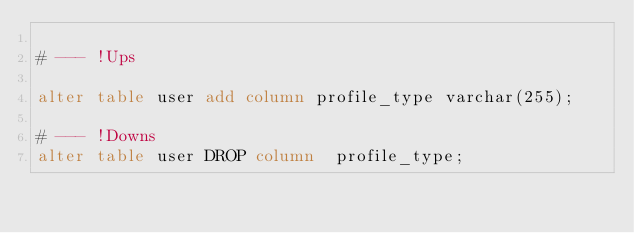Convert code to text. <code><loc_0><loc_0><loc_500><loc_500><_SQL_>
# --- !Ups

alter table user add column profile_type varchar(255);

# --- !Downs
alter table user DROP column  profile_type;
</code> 